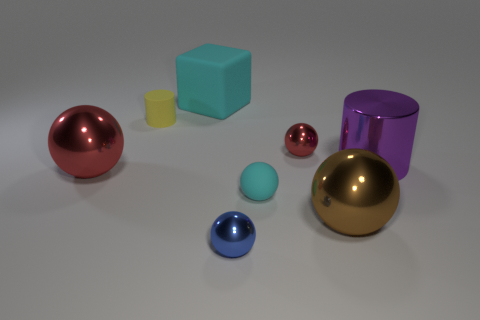Subtract all cyan rubber spheres. How many spheres are left? 4 Subtract all cylinders. How many objects are left? 6 Subtract 3 balls. How many balls are left? 2 Add 2 tiny blue shiny balls. How many objects exist? 10 Subtract all cyan balls. How many balls are left? 4 Subtract all cyan cylinders. How many brown balls are left? 1 Add 6 red shiny balls. How many red shiny balls are left? 8 Add 1 matte balls. How many matte balls exist? 2 Subtract 0 purple blocks. How many objects are left? 8 Subtract all gray balls. Subtract all gray cubes. How many balls are left? 5 